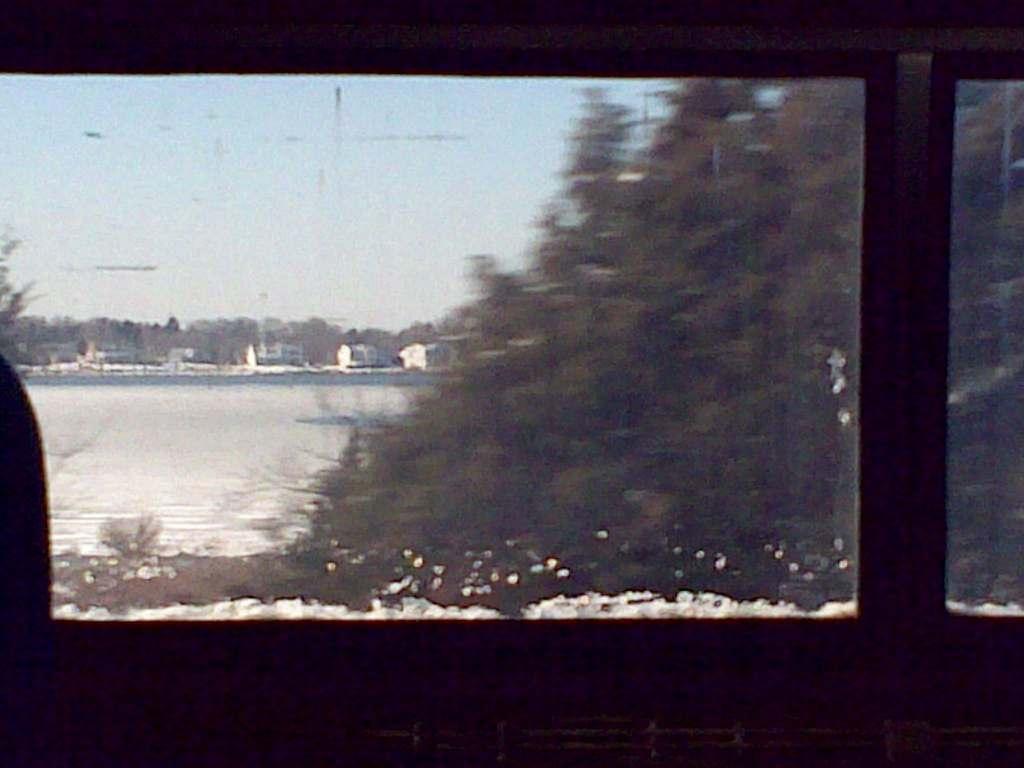Please provide a concise description of this image. In the foreground of this picture we can see there are some objects which seems to be the windows and through the windows we can see the sky, trees, snow and many other objects. 